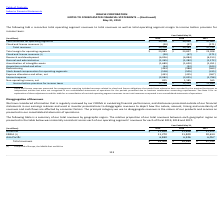Looking at Oracle Corporation's financial data, please calculate: How much was the research and development and restructuring expenses in 2019? Based on the calculation: 6,026+443 , the result is 6469 (in millions). This is based on the information: "research and development (6,026) (6,084) (6,153) restructuring (443) (588) (463)..." The key data points involved are: 443, 6,026. Also, can you calculate: How much was the percentage change in total revenues from 2017 to 2019? To answer this question, I need to perform calculations using the financial data. The calculation is: (39,506-37,792)/37,792 , which equals 4.54 (percentage). This is based on the information: "Total revenues $ 39,506 $ 39,383 $ 37,792 Total revenues $ 39,506 $ 39,383 $ 37,792..." The key data points involved are: 37,792, 39,506. Also, can you calculate: How much more was spent on interest expense than on stock-based compensation for operating segments in 2018? Based on the calculation: 2,025-505 , the result is 1520 (in millions). This is based on the information: "-based compensation for operating segments (518) (505) (415) Interest expense (2,082) (2,025) (1,798)..." The key data points involved are: 2,025, 505. Also, Which month was the financial year end? According to the financial document, May. The relevant text states: "ome before provision for income taxes: Year Ended May 31,..." Also, Does the values in the table represent values before or after provision of income taxes? The following tabl e reconciles total operating segment revenues to total revenues as well as total operating segment margin to income before provision for income taxes. The document states: "The following tabl e reconciles total operating segment revenues to total revenues as well as total operating segment margin to income before provisio..." Also, What was the amortization of intangible assets for 2019 and 2017? The document shows two values: 1,689 and 1,451 (in millions). From the document: "Amortization of intangible assets (1,689) (1,620) (1,451) mortization of intangible assets (1,689) (1,620) (1,451)..." 